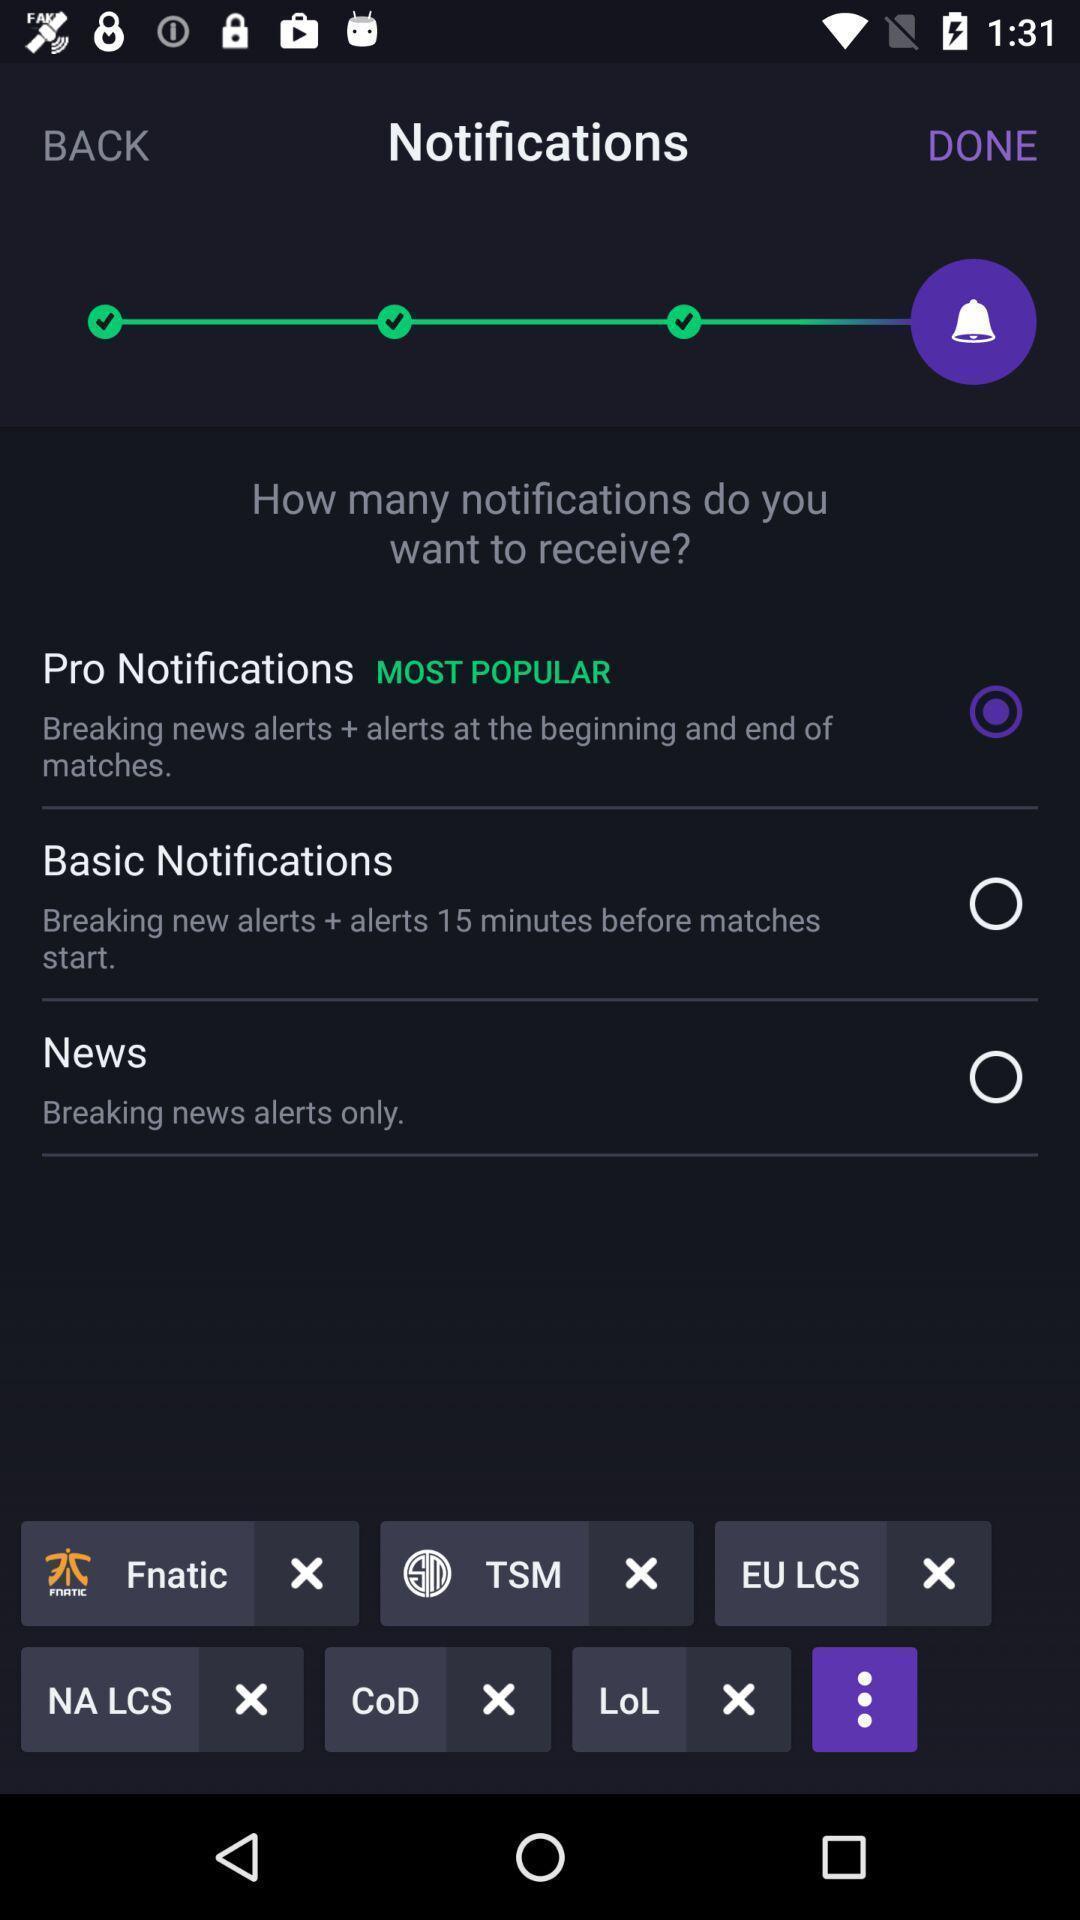Summarize the information in this screenshot. Page showing the options for notifications. 